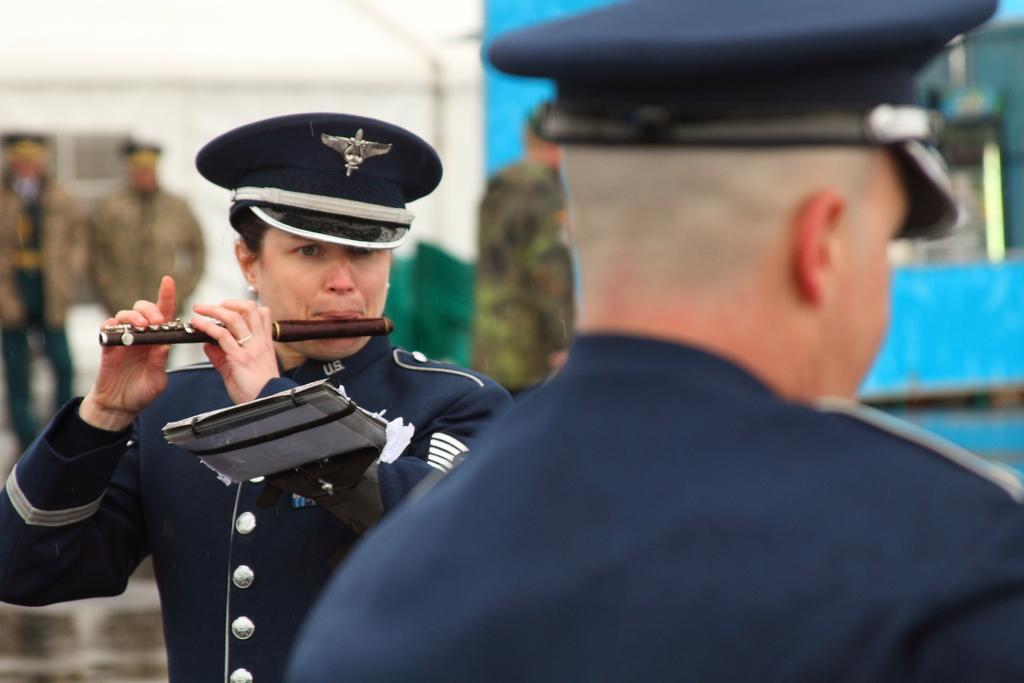Describe this image in one or two sentences. In this image in the front there is person. In the center there is a person standing and playing musical instrument. In the background there are persons and there are objects which are blue, white and green in colour. 